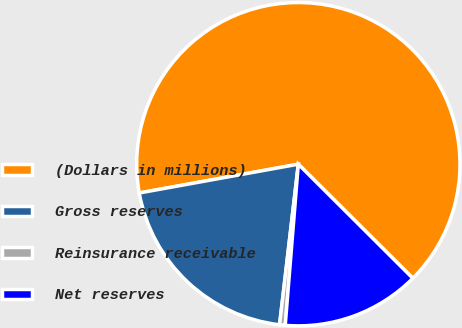<chart> <loc_0><loc_0><loc_500><loc_500><pie_chart><fcel>(Dollars in millions)<fcel>Gross reserves<fcel>Reinsurance receivable<fcel>Net reserves<nl><fcel>65.32%<fcel>20.3%<fcel>0.56%<fcel>13.82%<nl></chart> 